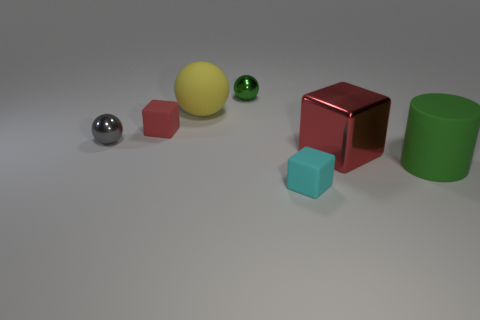There is a metallic block that is on the right side of the green sphere; what is its size?
Your response must be concise. Large. There is a green thing behind the big cube; are there any green spheres that are right of it?
Ensure brevity in your answer.  No. There is a tiny cube behind the big metallic block; does it have the same color as the object right of the big red shiny block?
Provide a short and direct response. No. The rubber ball has what color?
Make the answer very short. Yellow. Are there any other things that are the same color as the big matte cylinder?
Keep it short and to the point. Yes. What is the color of the rubber object that is both in front of the big red shiny cube and left of the large shiny thing?
Your response must be concise. Cyan. Do the cylinder that is on the right side of the yellow ball and the gray sphere have the same size?
Ensure brevity in your answer.  No. Are there more big red things that are right of the big green matte object than large gray rubber cylinders?
Offer a very short reply. No. Does the gray metallic thing have the same shape as the large green matte object?
Provide a succinct answer. No. The cyan cube has what size?
Your response must be concise. Small. 